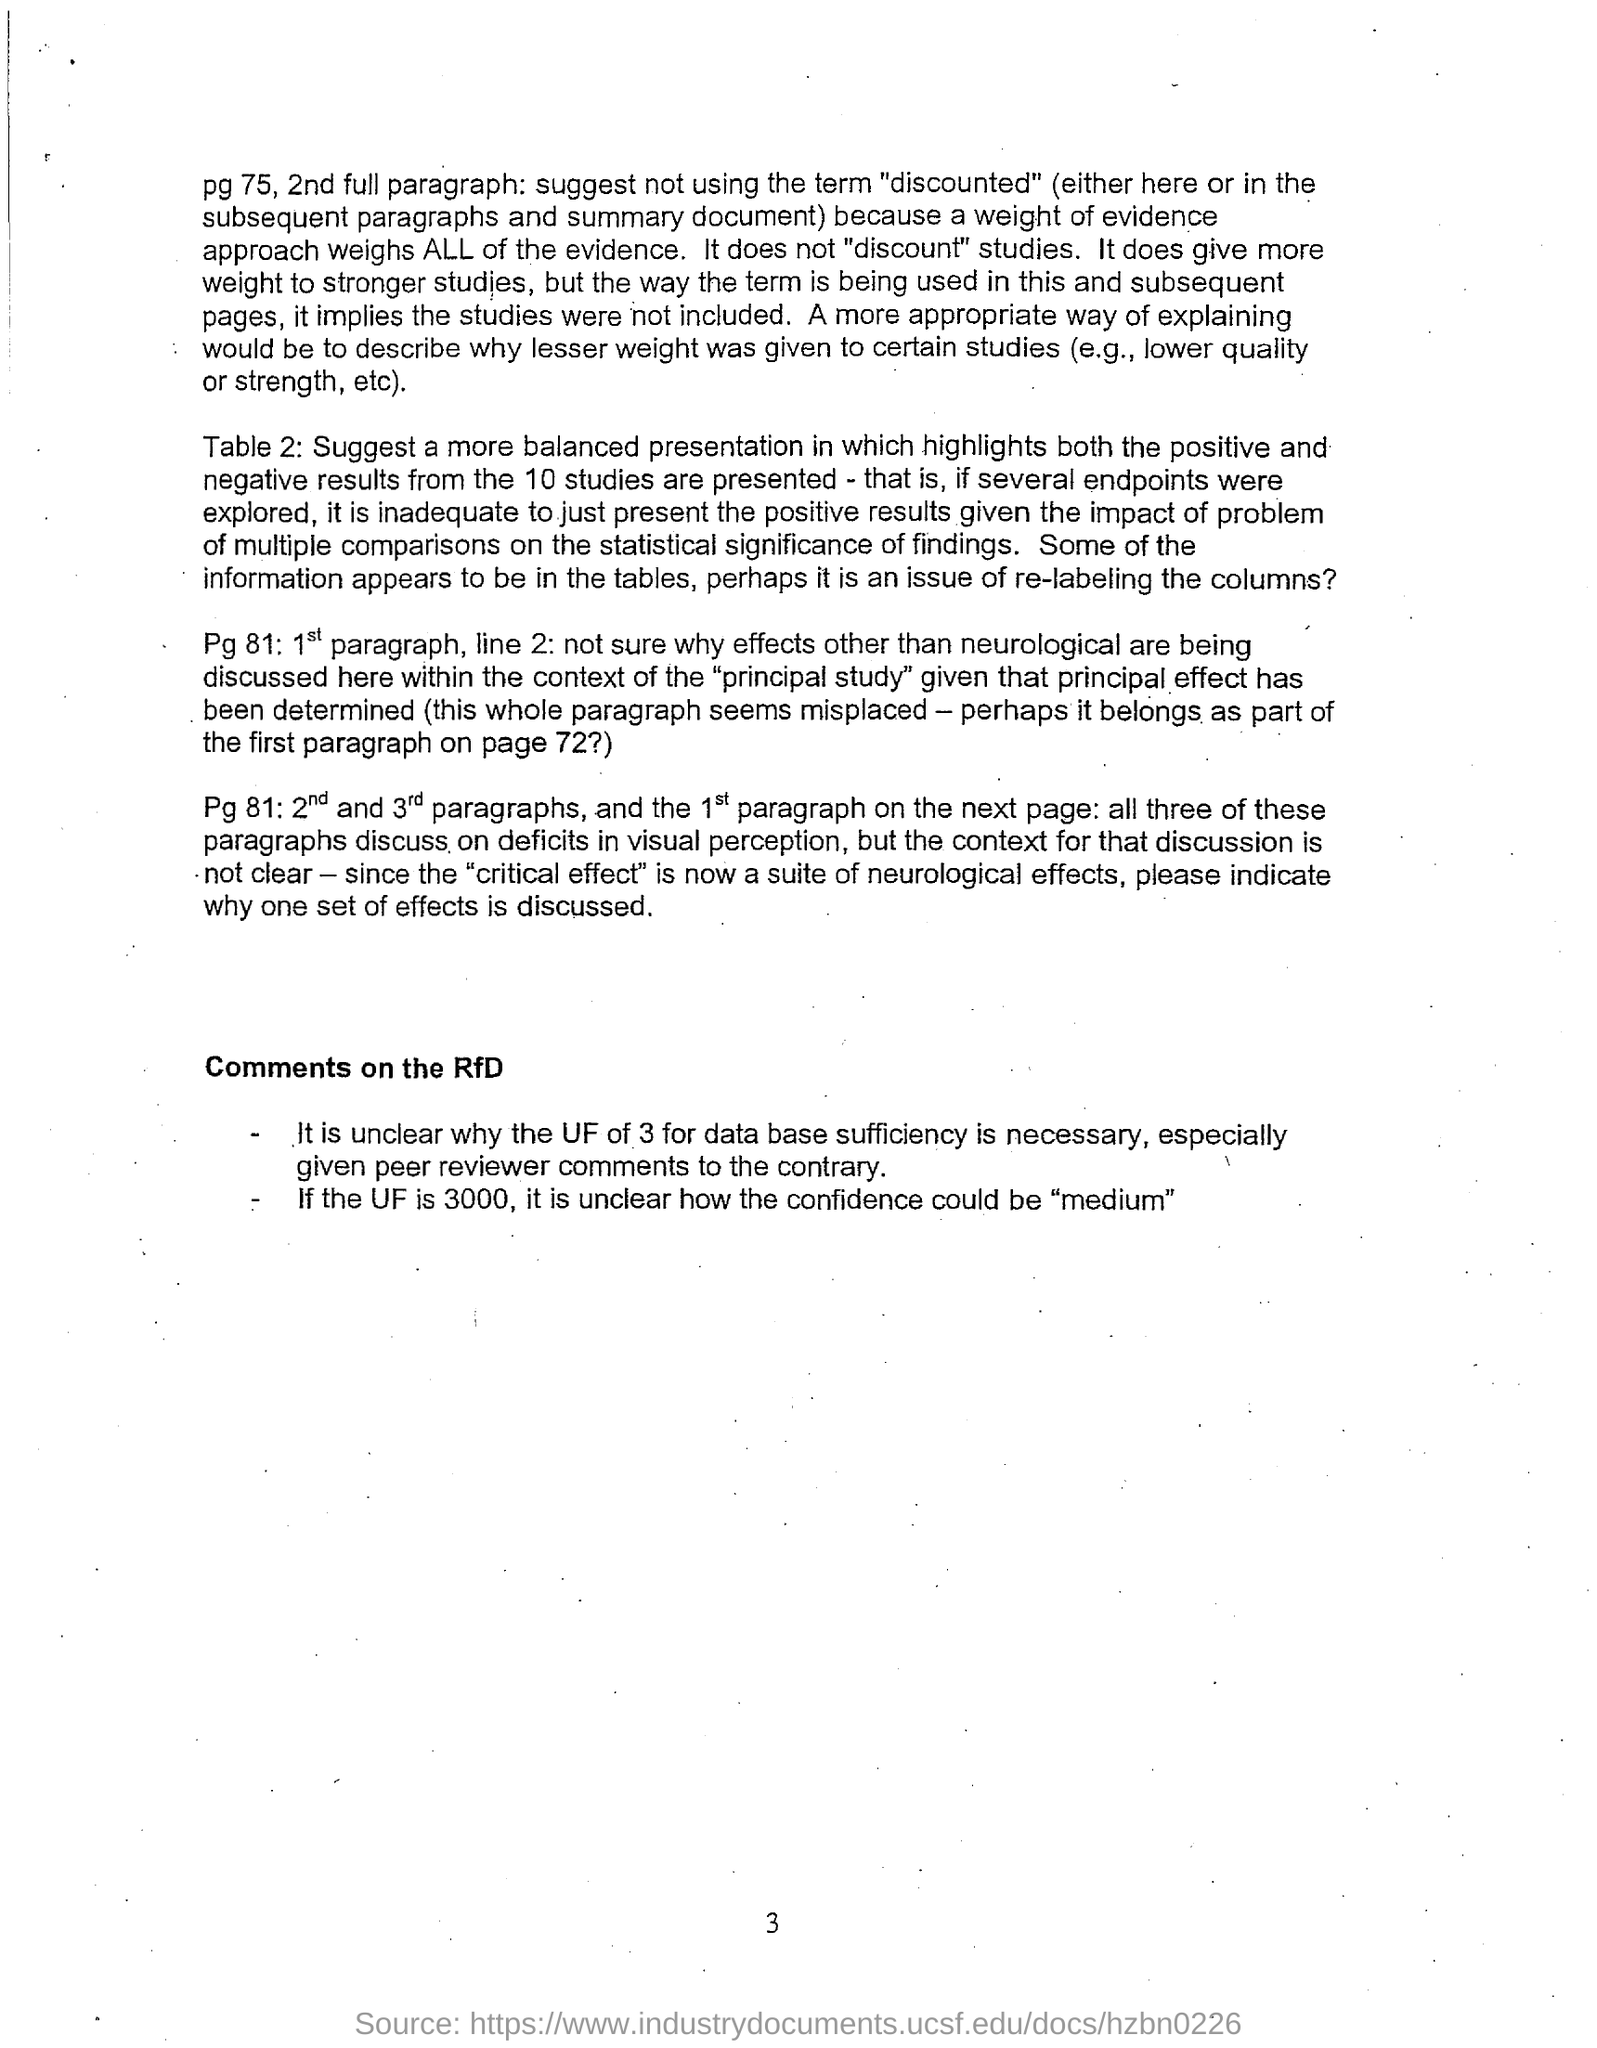Indicate a few pertinent items in this graphic. The second and third paragraphs on page 81, as well as the first paragraph on the following page, discuss the subject of deficits in visual perception. The subheading mentioned in this document is 'Comments on the RfD.' The page number mentioned in this document is 3. 